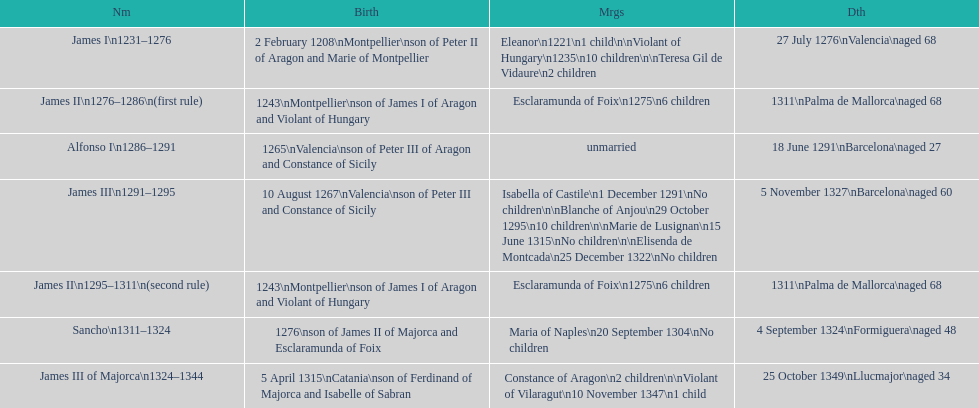What is the name that comes after james ii and before james iii? Alfonso I. 